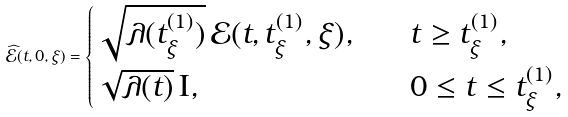Convert formula to latex. <formula><loc_0><loc_0><loc_500><loc_500>\widehat { \mathcal { E } } ( t , 0 , \xi ) = \begin{cases} \sqrt { \lambda ( t _ { \xi } ^ { ( 1 ) } ) } \, \mathcal { E } ( t , t _ { \xi } ^ { ( 1 ) } , \xi ) , \quad & t \geq t _ { \xi } ^ { ( 1 ) } , \\ \sqrt { \lambda ( t ) } \, \mathrm I , & 0 \leq t \leq t _ { \xi } ^ { ( 1 ) } , \end{cases}</formula> 